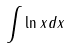<formula> <loc_0><loc_0><loc_500><loc_500>\int \ln x d x</formula> 